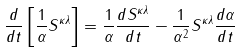<formula> <loc_0><loc_0><loc_500><loc_500>\frac { d } { d t } \left [ \frac { 1 } { \alpha } S ^ { \kappa \lambda } \right ] = \frac { 1 } { \alpha } \frac { d S ^ { \kappa \lambda } } { d t } - \frac { 1 } { \alpha ^ { 2 } } S ^ { \kappa \lambda } \frac { d \alpha } { d t }</formula> 